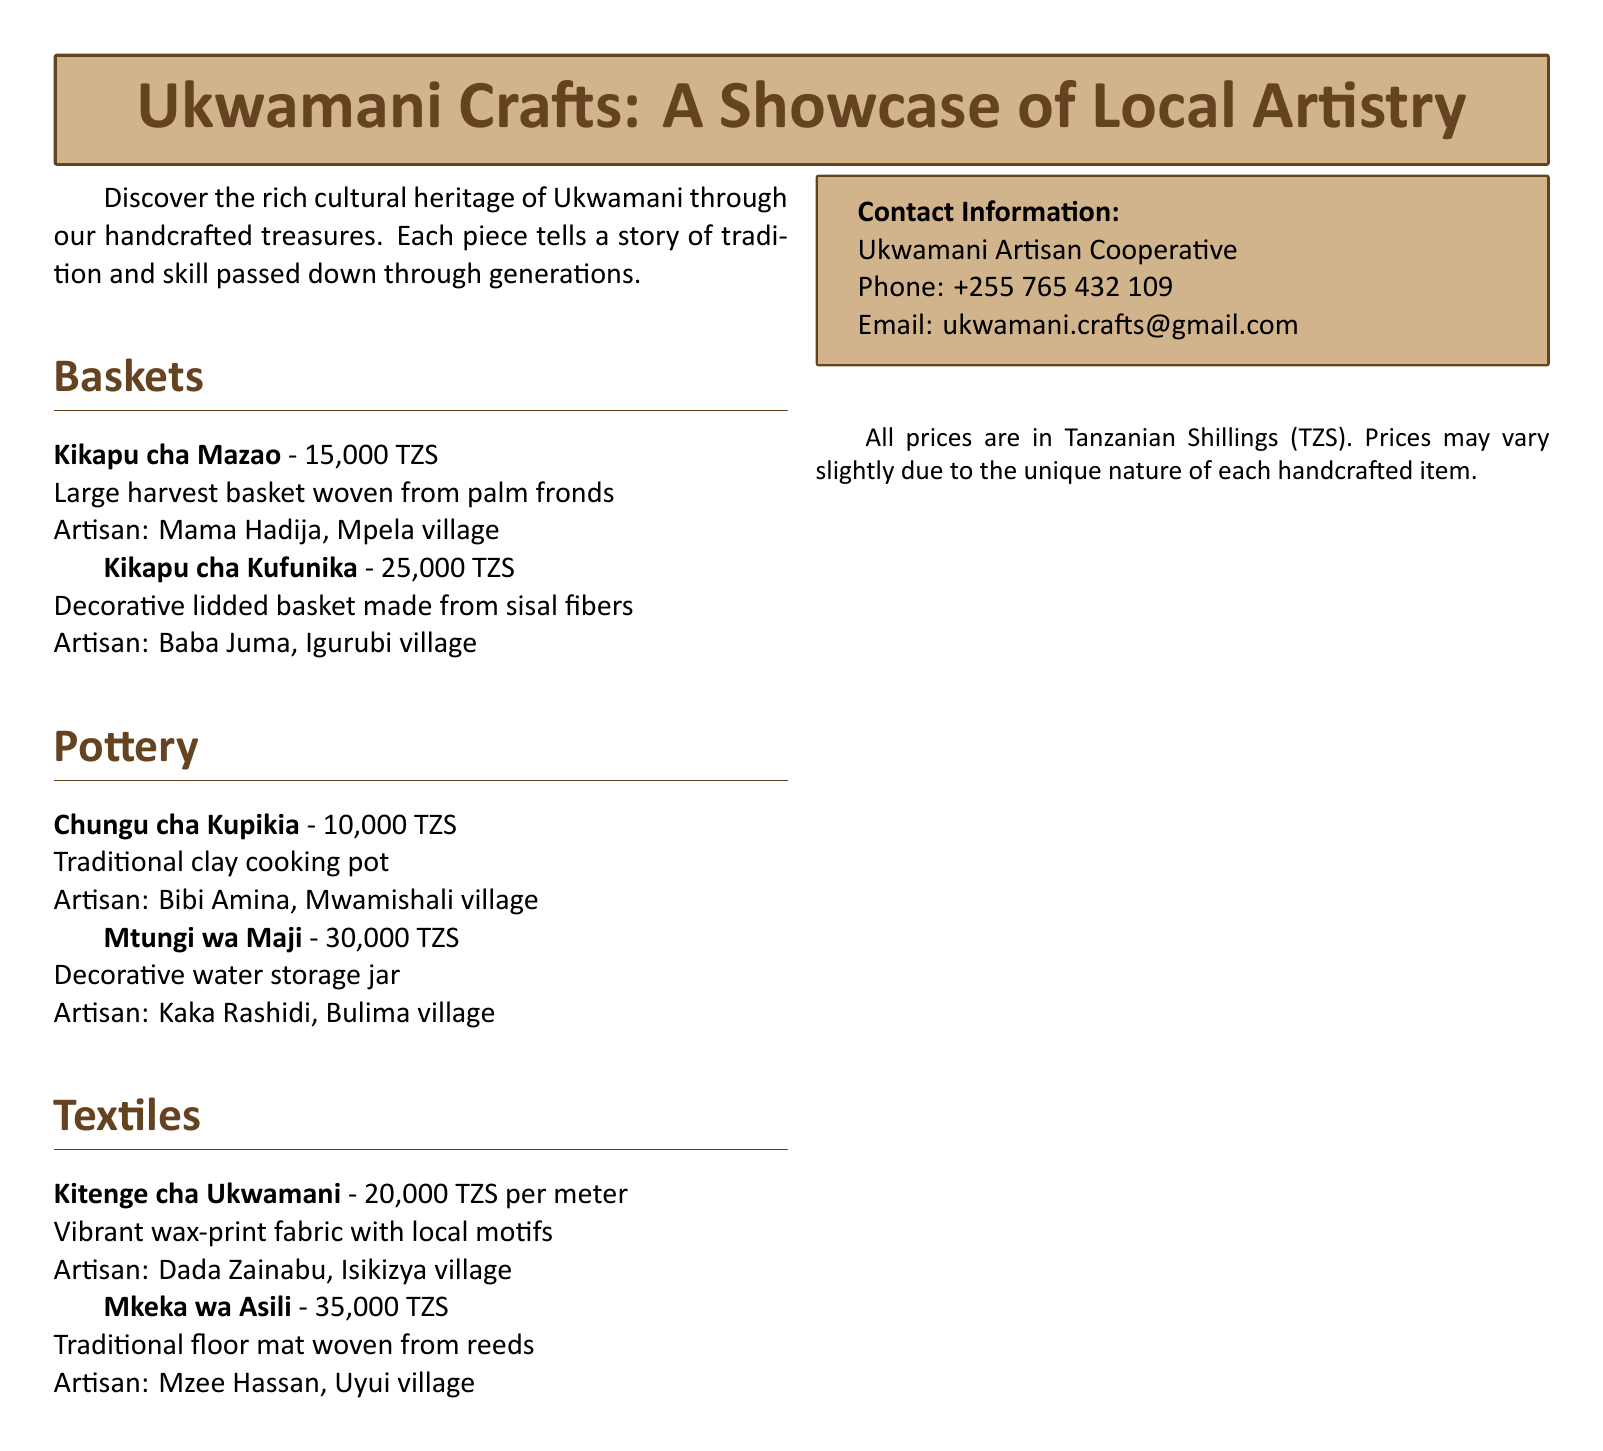What is the price of Kikapu cha Mazao? The price is listed in the document under the baskets section, and it states that Kikapu cha Mazao costs 15,000 TZS.
Answer: 15,000 TZS Who is the artisan of Mkeka wa Asili? The document specifies that Mkeka wa Asili is crafted by Mzee Hassan from Uyui village.
Answer: Mzee Hassan What type of material is used for Kikapu cha Kufunika? The material used for Kikapu cha Kufunika is sisal fibers as mentioned in the document.
Answer: Sisal fibers How much does Chungu cha Kupikia cost? The cost of Chungu cha Kupikia is found in the pottery section, which states it is 10,000 TZS.
Answer: 10,000 TZS How many artisans are mentioned in the document? The document lists 6 artisans across different sections, making the total number of artisans mentioned 6.
Answer: 6 What is the unique feature of Kitenge cha Ukwamani? The document describes Kitenge cha Ukwamani as a vibrant wax-print fabric with local motifs, highlighting its unique characteristics.
Answer: Vibrant wax-print fabric with local motifs Which village does Baba Juma come from? Baba Juma, the artisan of Kikapu cha Kufunika, is from Igurubi village, as stated in the document.
Answer: Igurubi village What is the price per meter for Kitenge cha Ukwamani? The document specifies that Kitenge cha Ukwamani costs 20,000 TZS per meter.
Answer: 20,000 TZS per meter 